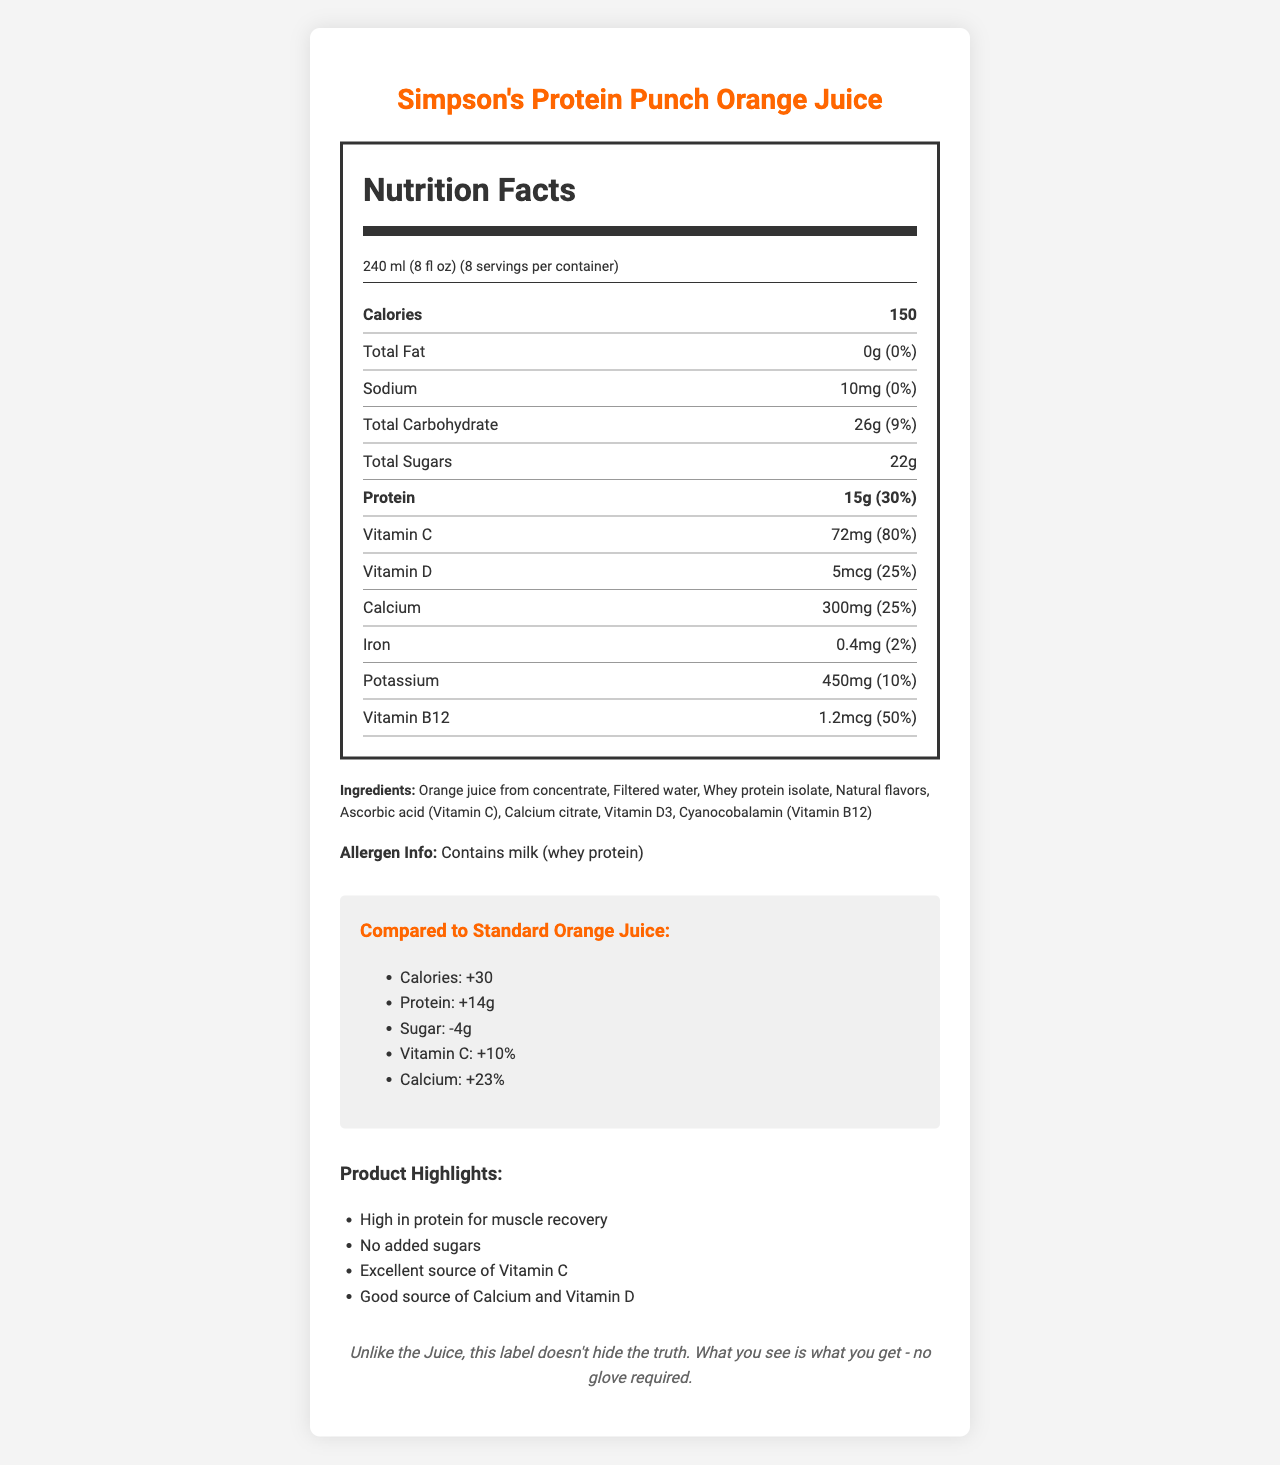what is the serving size? The serving size is listed under "Nutrition Facts" at the top of the label.
Answer: 240 ml (8 fl oz) how much protein is in a serving? The protein content is displayed prominently in the "Nutrition Facts" section, under Total Sugars.
Answer: 15g What percentage of the daily value of Vitamin C does a serving provide? This information is listed under the Vitamin C nutrient row in the "Nutrition Facts" section.
Answer: 80% how many calories are in a serving compared to standard orange juice? The comparison with standard orange juice shows a "+30" calorie difference, listed in the comparison section.
Answer: +30 calories Which ingredient is a potential allergen? The allergen information is clearly stated below the ingredient list in the document.
Answer: Whey protein (milk) How much calcium is provided per serving? The calcium amount is listed in the "Nutrition Facts" under the nutrient rows, specifically under "Calcium."
Answer: 300mg What is the main protein source in this orange juice? A. Soy protein B. Whey protein C. Pea protein The ingredient list clearly states "Whey protein isolate", indicating that whey protein is the main protein source.
Answer: B What marketing claim emphasizes muscle recovery? A. Excellent source of Vitamin C B. High in protein C. Good source of Calcium and Vitamin D "High in protein for muscle recovery" is one of the marketing claims listed under "Product Highlights."
Answer: B Is there any added sugar in Simpson's Protein Punch Orange Juice? The Nutrition Facts label specifically states "0g" added sugars.
Answer: No Does a serving of this juice provide more or less sugar compared to standard orange juice? The comparison section indicates a "-4g" difference in sugar, meaning this juice contains 4 grams less sugar than standard orange juice.
Answer: Less Summarize the main nutritional differences between Simpson's Protein Punch Orange Juice and standard orange juice. The comparison section outlines these key differences, providing a clear contrast on these nutritional aspects.
Answer: Simpson's Protein Punch Orange Juice has more calories (+30), significantly higher protein content (+14g), less sugar (-4g), and higher percentages of Vitamin C (+10%) and calcium (+23%) compared to standard orange juice. What is the purpose of the note at the bottom of the document? This note uses a metaphor to suggest that the nutritional facts and ingredients are presented honestly, without deception.
Answer: It comments on the transparency of the label, stating, "What you see is what you get - no glove required." How much iron is contained in each serving? The iron content is listed in the "Nutrition Facts" section alongside other nutrients.
Answer: 0.4mg What is the daily value percentage of Vitamin B12 in a serving? This information is found under the nutrient rows in "Nutrition Facts," specifically within the Vitamin B12 row.
Answer: 50% Can't someone with a milk allergy drink this juice? The allergen information clearly states that the product contains milk (whey protein), making it unsuitable for those with a milk allergy.
Answer: No Is the calorie content in this juice derived mostly from protein or carbohydrates? The document does not provide enough information to ascertain whether calories are predominantly from protein or carbohydrates.
Answer: Cannot be determined 